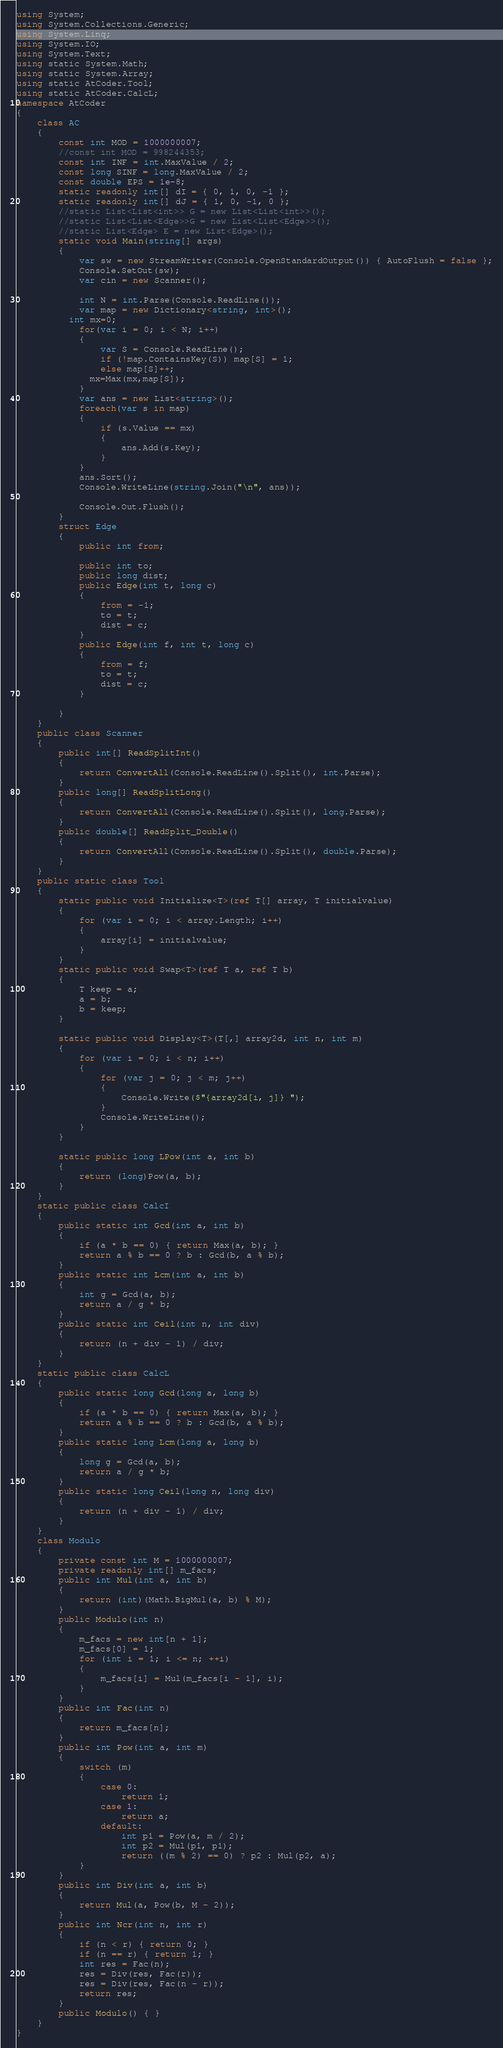Convert code to text. <code><loc_0><loc_0><loc_500><loc_500><_C#_>using System;
using System.Collections.Generic;
using System.Linq;
using System.IO;
using System.Text;
using static System.Math;
using static System.Array;
using static AtCoder.Tool;
using static AtCoder.CalcL;
namespace AtCoder
{
    class AC
    {
        const int MOD = 1000000007;
        //const int MOD = 998244353;
        const int INF = int.MaxValue / 2;
        const long SINF = long.MaxValue / 2;
        const double EPS = 1e-8;
        static readonly int[] dI = { 0, 1, 0, -1 };
        static readonly int[] dJ = { 1, 0, -1, 0 };
        //static List<List<int>> G = new List<List<int>>();
        //static List<List<Edge>>G = new List<List<Edge>>();
        //static List<Edge> E = new List<Edge>();
        static void Main(string[] args)
        {
            var sw = new StreamWriter(Console.OpenStandardOutput()) { AutoFlush = false };
            Console.SetOut(sw);
            var cin = new Scanner();

            int N = int.Parse(Console.ReadLine());
            var map = new Dictionary<string, int>();
          int mx=0;
            for(var i = 0; i < N; i++)
            {
                var S = Console.ReadLine();
                if (!map.ContainsKey(S)) map[S] = 1;
                else map[S]++;
              mx=Max(mx,map[S]);
            }
            var ans = new List<string>();
            foreach(var s in map)
            {
                if (s.Value == mx)
                {
                    ans.Add(s.Key);
                }
            }
            ans.Sort();
            Console.WriteLine(string.Join("\n", ans));

            Console.Out.Flush();
        }
        struct Edge
        {
            public int from;

            public int to;
            public long dist;
            public Edge(int t, long c)
            {
                from = -1;
                to = t;
                dist = c;
            }
            public Edge(int f, int t, long c)
            {
                from = f;
                to = t;
                dist = c;
            }

        }
    }
    public class Scanner
    {
        public int[] ReadSplitInt()
        {
            return ConvertAll(Console.ReadLine().Split(), int.Parse);
        }
        public long[] ReadSplitLong()
        {
            return ConvertAll(Console.ReadLine().Split(), long.Parse);
        }
        public double[] ReadSplit_Double()
        {
            return ConvertAll(Console.ReadLine().Split(), double.Parse);
        }
    }
    public static class Tool
    {
        static public void Initialize<T>(ref T[] array, T initialvalue)
        {
            for (var i = 0; i < array.Length; i++)
            {
                array[i] = initialvalue;
            }
        }
        static public void Swap<T>(ref T a, ref T b)
        {
            T keep = a;
            a = b;
            b = keep;
        }

        static public void Display<T>(T[,] array2d, int n, int m)
        {
            for (var i = 0; i < n; i++)
            {
                for (var j = 0; j < m; j++)
                {
                    Console.Write($"{array2d[i, j]} ");
                }
                Console.WriteLine();
            }
        }

        static public long LPow(int a, int b)
        {
            return (long)Pow(a, b);
        }
    }
    static public class CalcI
    {
        public static int Gcd(int a, int b)
        {
            if (a * b == 0) { return Max(a, b); }
            return a % b == 0 ? b : Gcd(b, a % b);
        }
        public static int Lcm(int a, int b)
        {
            int g = Gcd(a, b);
            return a / g * b;
        }
        public static int Ceil(int n, int div)
        {
            return (n + div - 1) / div;
        }
    }
    static public class CalcL
    {
        public static long Gcd(long a, long b)
        {
            if (a * b == 0) { return Max(a, b); }
            return a % b == 0 ? b : Gcd(b, a % b);
        }
        public static long Lcm(long a, long b)
        {
            long g = Gcd(a, b);
            return a / g * b;
        }
        public static long Ceil(long n, long div)
        {
            return (n + div - 1) / div;
        }
    }
    class Modulo
    {
        private const int M = 1000000007;
        private readonly int[] m_facs;
        public int Mul(int a, int b)
        {
            return (int)(Math.BigMul(a, b) % M);
        }
        public Modulo(int n)
        {
            m_facs = new int[n + 1];
            m_facs[0] = 1;
            for (int i = 1; i <= n; ++i)
            {
                m_facs[i] = Mul(m_facs[i - 1], i);
            }
        }
        public int Fac(int n)
        {
            return m_facs[n];
        }
        public int Pow(int a, int m)
        {
            switch (m)
            {
                case 0:
                    return 1;
                case 1:
                    return a;
                default:
                    int p1 = Pow(a, m / 2);
                    int p2 = Mul(p1, p1);
                    return ((m % 2) == 0) ? p2 : Mul(p2, a);
            }
        }
        public int Div(int a, int b)
        {
            return Mul(a, Pow(b, M - 2));
        }
        public int Ncr(int n, int r)
        {
            if (n < r) { return 0; }
            if (n == r) { return 1; }
            int res = Fac(n);
            res = Div(res, Fac(r));
            res = Div(res, Fac(n - r));
            return res;
        }
        public Modulo() { }
    }
}
</code> 